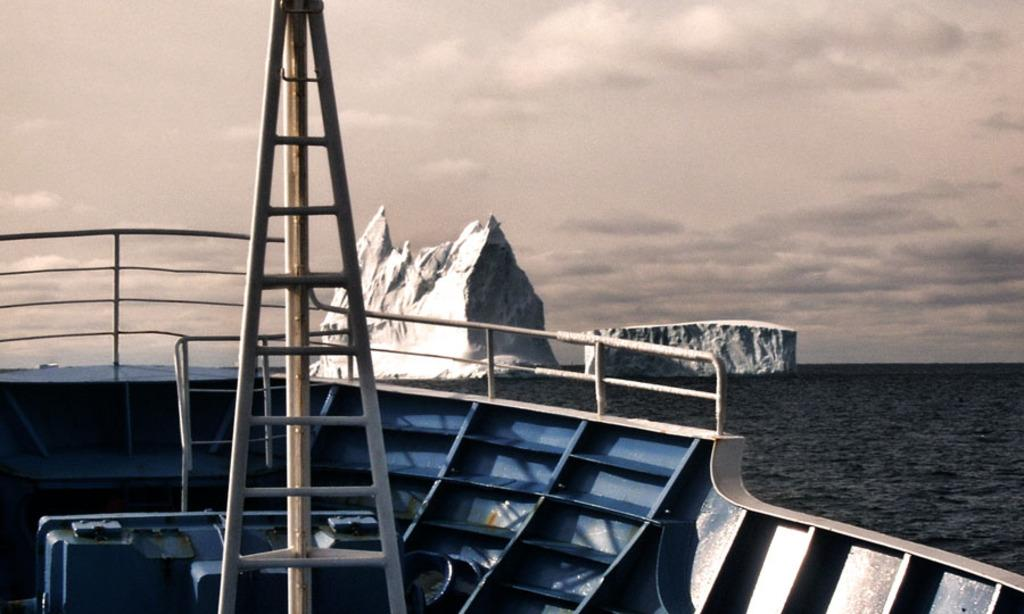What type of structure is visible in the image? There is a part of a ship with railing in the image. What feature is present on the ship for climbing or descending? There is a ladder in the image. What natural formations can be seen in the water in the background of the image? Icebergs are visible in the water in the background of the image. What part of the natural environment is visible in the background of the image? There is sky visible in the background of the image. What can be observed in the sky? Clouds are present in the sky. What type of feast is being prepared on the ship in the image? There is no indication of a feast being prepared in the image; it only shows a part of a ship with railing, a ladder, and the surrounding environment. 